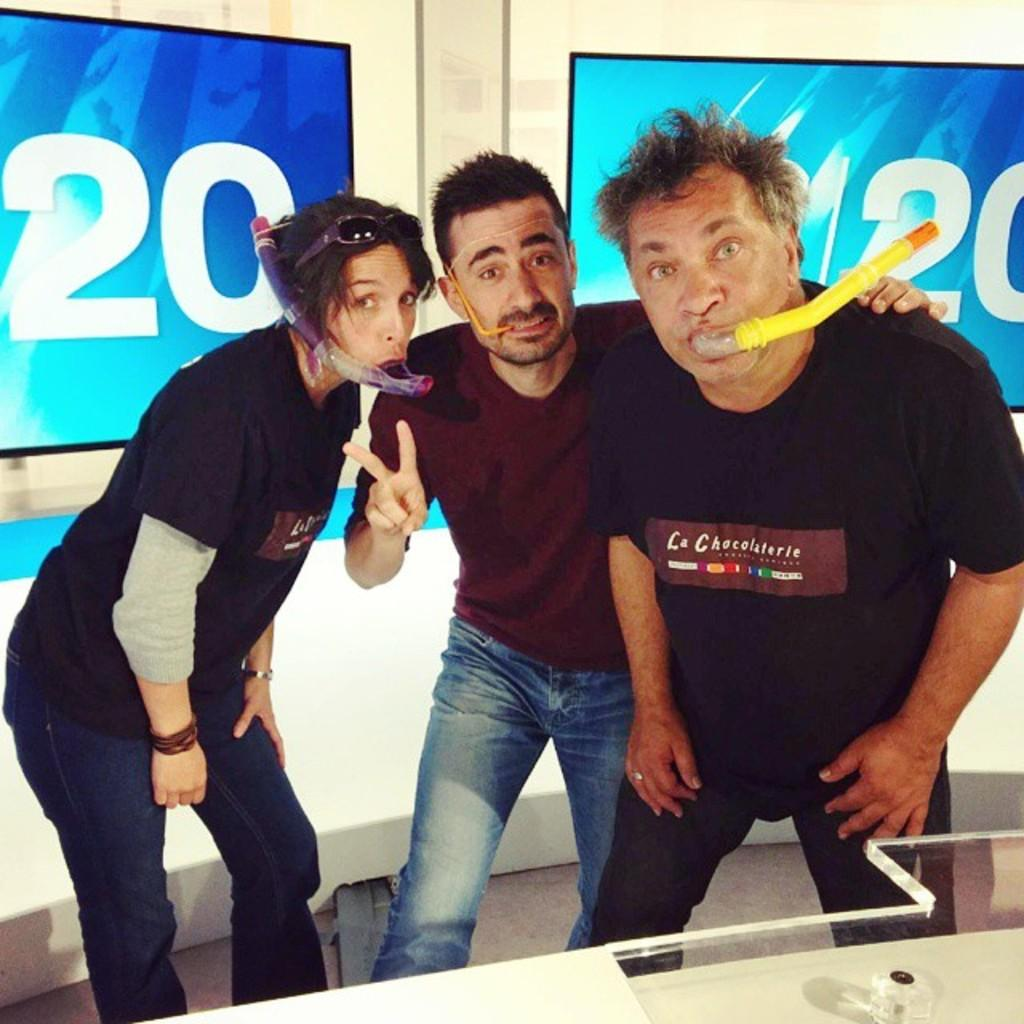How many people are in the image? There are two men and a woman standing in the image. What can be seen in the background of the image? There are pipes visible in the image. What type of equipment is present in the image? There are screens with displays in the image. Where are the screens located in the image? The screens are attached to the wall. What type of furniture is in the image? There is a glass table in the image. What type of yard can be seen in the image? There is no yard visible in the image; it features people, pipes, screens, and a glass table. 